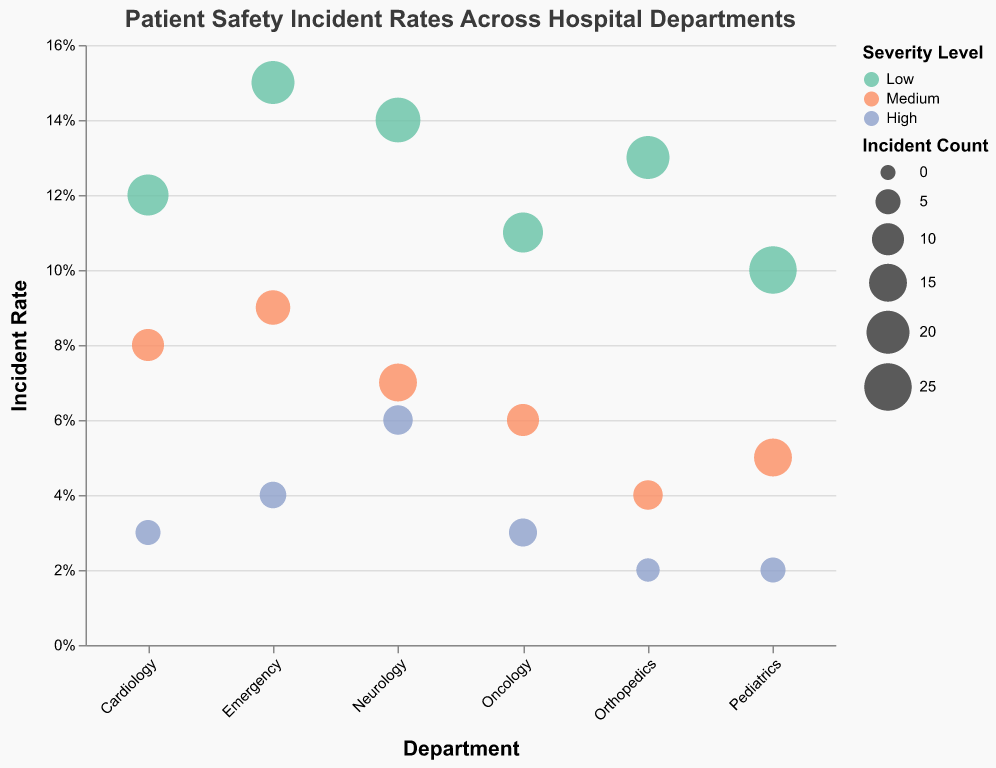What is the title of the figure? The title is prominently displayed at the top of the figure, which reads: "Patient Safety Incident Rates Across Hospital Departments".
Answer: Patient Safety Incident Rates Across Hospital Departments Which department has the highest incident rate for low severity cases? By examining the department categories on the x-axis and their corresponding low severity incident rates on the y-axis, Neurology has the highest incident rate for low severity cases at 0.14.
Answer: Neurology How many low severity incidents were reported in the Pediatrics department? The size of the bubble for low severity incidents in Pediatrics indicates the incident count, which is 25.
Answer: 25 Compare the incident rates of high severity cases between Oncology and Orthopedics departments. Look at the bubbles representing high severity cases (color-coded) in Oncology and Orthopedics. Oncology has an incident rate of 0.03, while Orthopedics has a rate of 0.02.
Answer: Oncology has a higher incident rate for high severity cases What is the range of incident rates for medium severity cases across all departments? By inspecting the vertical positions of all medium severity case bubbles, the range is from the lowest medium severity rate (0.04 in Orthopedics) to the highest (0.09 in Emergency).
Answer: 0.04 to 0.09 Which department has the largest number of incident counts overall? By comparing the sizes of all bubbles in each department, Pediatrics has the largest total incident counts across all severity levels, the largest size bubble being 25.
Answer: Pediatrics What is the average incident rate for high severity cases across all departments? Calculate the sum of all high severity incident rates (0.04 + 0.03 + 0.06 + 0.02 + 0.03 + 0.02 = 0.2) and divide by the number of departments (6). Average rate = 0.2/6 = 0.033 (approximately).
Answer: 0.033 In which department do medium severity incidents have the lowest incident count? Observing the size of bubbles for medium severity incidents across all departments, Orthopedics has the smallest bubble indicating the lowest count of 8.
Answer: Orthopedics What is the relationship between incident count and incident rate for high severity cases in the Emergency department? The Emergency department's high severity bubble has an incident count of 6 and an incident rate of 0.04, showing a comparatively low rate for a moderate count.
Answer: Low rate, moderate count 